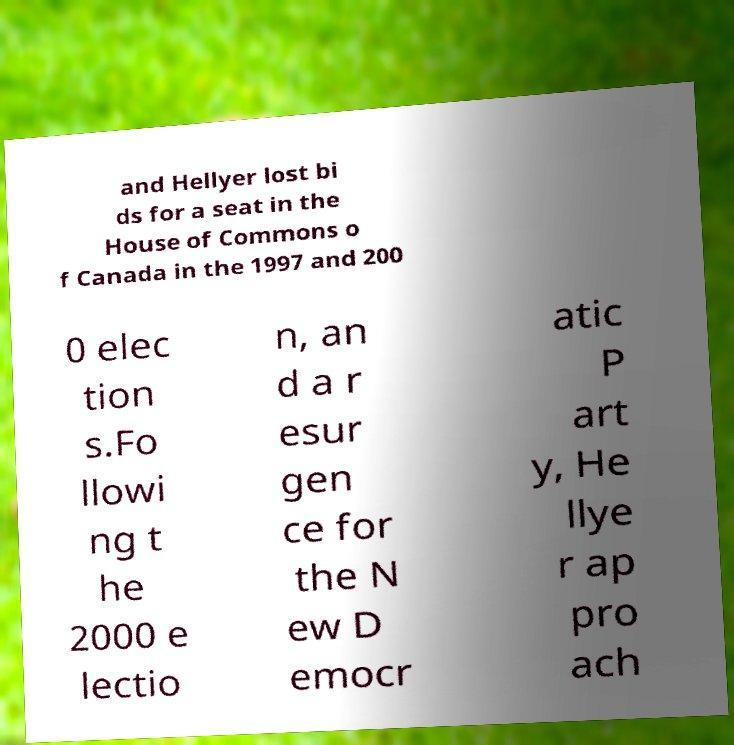There's text embedded in this image that I need extracted. Can you transcribe it verbatim? and Hellyer lost bi ds for a seat in the House of Commons o f Canada in the 1997 and 200 0 elec tion s.Fo llowi ng t he 2000 e lectio n, an d a r esur gen ce for the N ew D emocr atic P art y, He llye r ap pro ach 